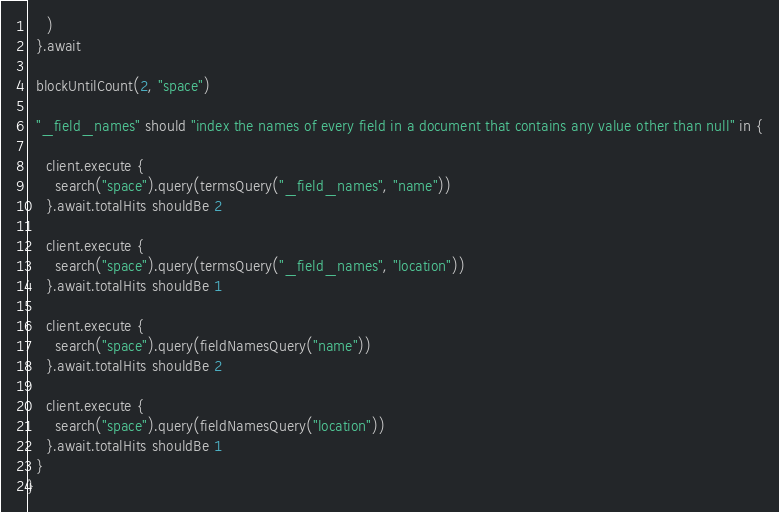<code> <loc_0><loc_0><loc_500><loc_500><_Scala_>    )
  }.await

  blockUntilCount(2, "space")

  "_field_names" should "index the names of every field in a document that contains any value other than null" in {

    client.execute {
      search("space").query(termsQuery("_field_names", "name"))
    }.await.totalHits shouldBe 2

    client.execute {
      search("space").query(termsQuery("_field_names", "location"))
    }.await.totalHits shouldBe 1

    client.execute {
      search("space").query(fieldNamesQuery("name"))
    }.await.totalHits shouldBe 2

    client.execute {
      search("space").query(fieldNamesQuery("location"))
    }.await.totalHits shouldBe 1
  }
}
</code> 